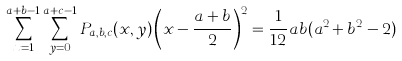<formula> <loc_0><loc_0><loc_500><loc_500>\sum _ { x = 1 } ^ { a + b - 1 } \sum _ { y = 0 } ^ { a + c - 1 } P _ { a , b , c } ( x , y ) \left ( x - \frac { a + b } { 2 } \right ) ^ { 2 } = \frac { 1 } { 1 2 } a b ( a ^ { 2 } + b ^ { 2 } - 2 )</formula> 